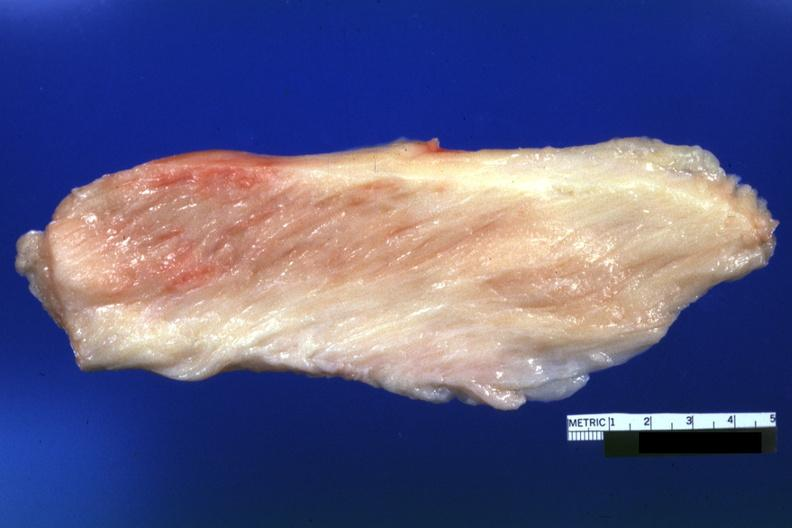s acute lymphocytic leukemia present?
Answer the question using a single word or phrase. No 